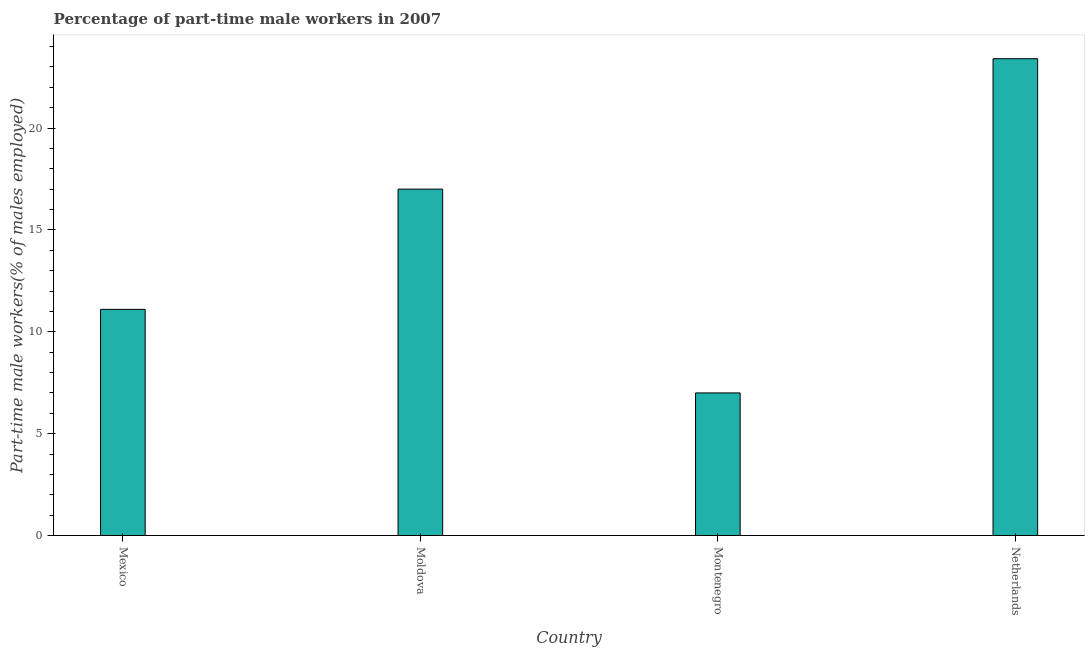Does the graph contain any zero values?
Offer a terse response. No. What is the title of the graph?
Offer a terse response. Percentage of part-time male workers in 2007. What is the label or title of the X-axis?
Offer a very short reply. Country. What is the label or title of the Y-axis?
Provide a short and direct response. Part-time male workers(% of males employed). Across all countries, what is the maximum percentage of part-time male workers?
Your response must be concise. 23.4. Across all countries, what is the minimum percentage of part-time male workers?
Give a very brief answer. 7. In which country was the percentage of part-time male workers minimum?
Make the answer very short. Montenegro. What is the sum of the percentage of part-time male workers?
Provide a short and direct response. 58.5. What is the difference between the percentage of part-time male workers in Montenegro and Netherlands?
Provide a succinct answer. -16.4. What is the average percentage of part-time male workers per country?
Your response must be concise. 14.62. What is the median percentage of part-time male workers?
Ensure brevity in your answer.  14.05. In how many countries, is the percentage of part-time male workers greater than 21 %?
Your answer should be very brief. 1. What is the ratio of the percentage of part-time male workers in Mexico to that in Moldova?
Keep it short and to the point. 0.65. Is the sum of the percentage of part-time male workers in Moldova and Netherlands greater than the maximum percentage of part-time male workers across all countries?
Ensure brevity in your answer.  Yes. In how many countries, is the percentage of part-time male workers greater than the average percentage of part-time male workers taken over all countries?
Make the answer very short. 2. How many bars are there?
Offer a very short reply. 4. What is the Part-time male workers(% of males employed) of Mexico?
Give a very brief answer. 11.1. What is the Part-time male workers(% of males employed) of Netherlands?
Make the answer very short. 23.4. What is the difference between the Part-time male workers(% of males employed) in Mexico and Moldova?
Your answer should be very brief. -5.9. What is the difference between the Part-time male workers(% of males employed) in Mexico and Montenegro?
Make the answer very short. 4.1. What is the difference between the Part-time male workers(% of males employed) in Montenegro and Netherlands?
Give a very brief answer. -16.4. What is the ratio of the Part-time male workers(% of males employed) in Mexico to that in Moldova?
Your answer should be compact. 0.65. What is the ratio of the Part-time male workers(% of males employed) in Mexico to that in Montenegro?
Offer a terse response. 1.59. What is the ratio of the Part-time male workers(% of males employed) in Mexico to that in Netherlands?
Ensure brevity in your answer.  0.47. What is the ratio of the Part-time male workers(% of males employed) in Moldova to that in Montenegro?
Keep it short and to the point. 2.43. What is the ratio of the Part-time male workers(% of males employed) in Moldova to that in Netherlands?
Provide a short and direct response. 0.73. What is the ratio of the Part-time male workers(% of males employed) in Montenegro to that in Netherlands?
Your answer should be very brief. 0.3. 